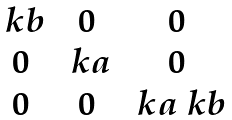Convert formula to latex. <formula><loc_0><loc_0><loc_500><loc_500>\begin{matrix} \ k b & 0 & 0 \\ 0 & \ k a & 0 \\ 0 & 0 & \ k a \ k b \end{matrix}</formula> 